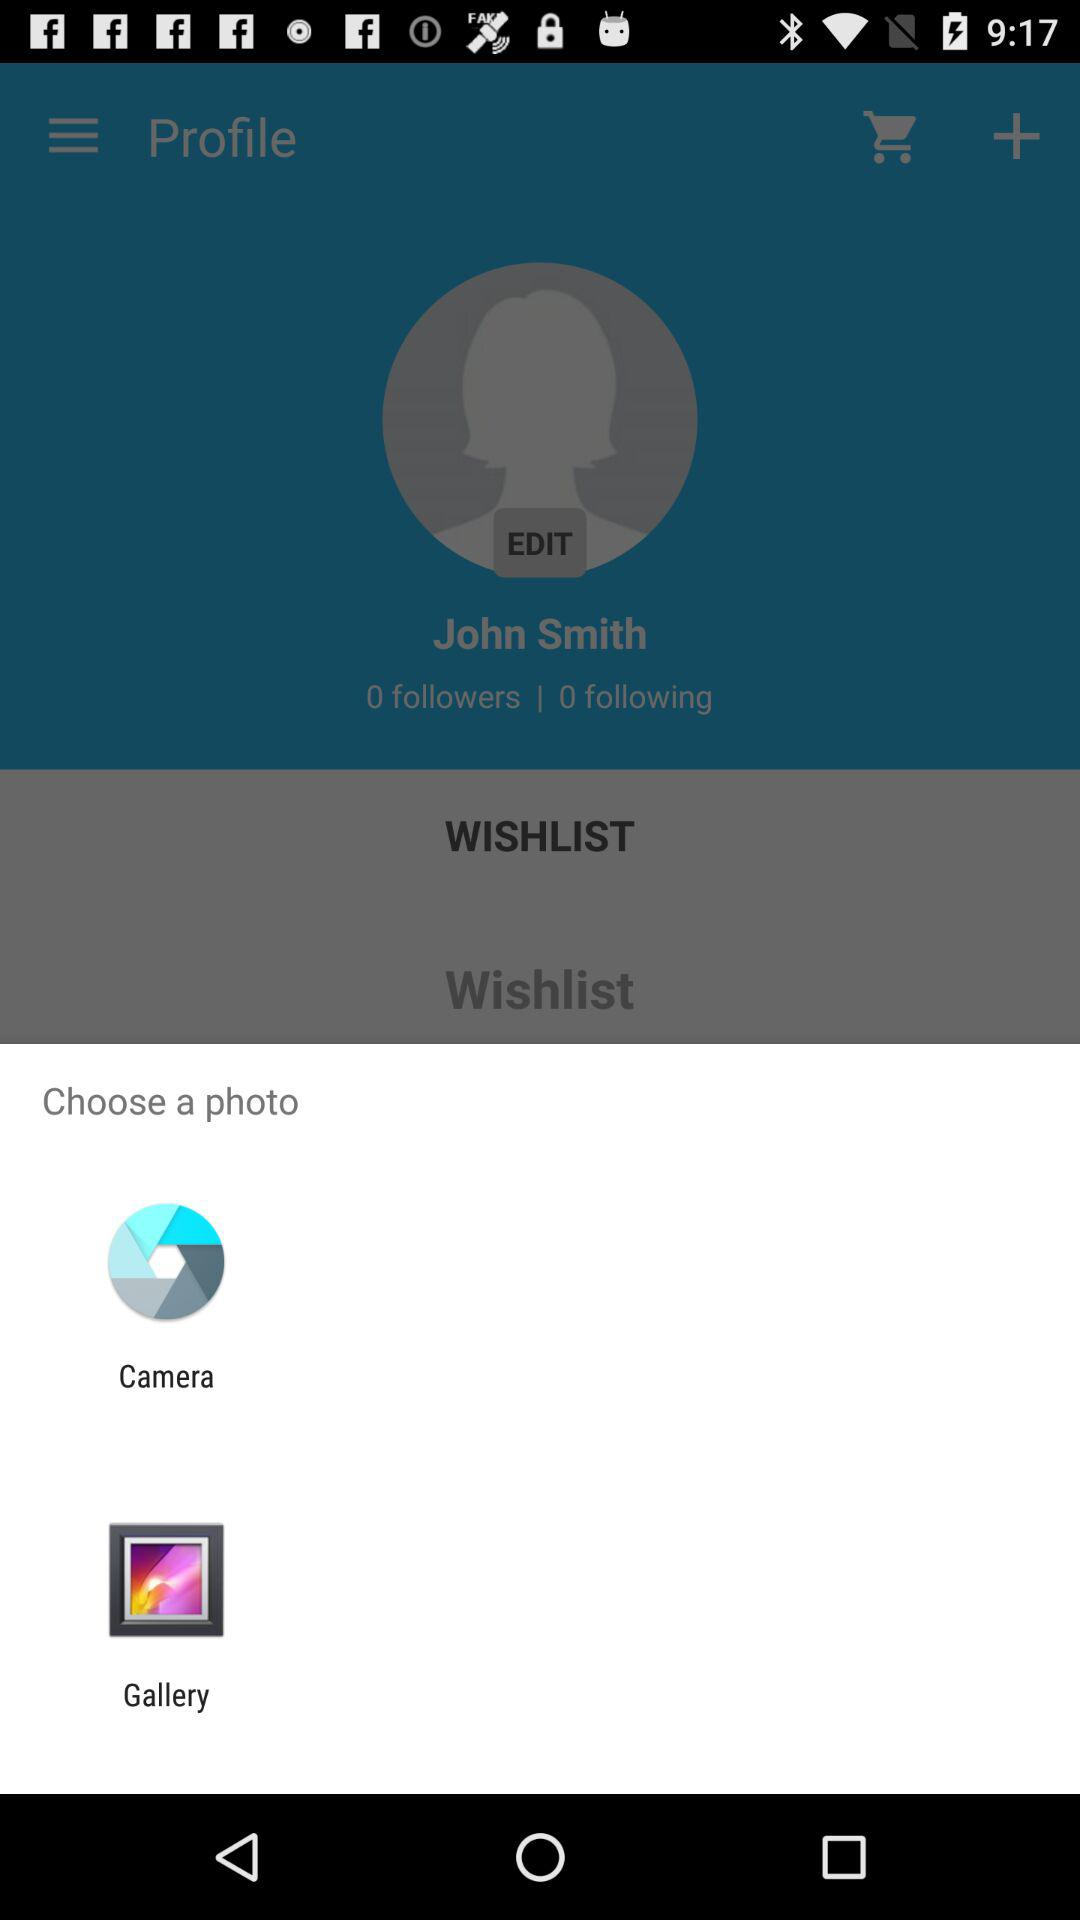What is the user name? The user name is John Smith. 